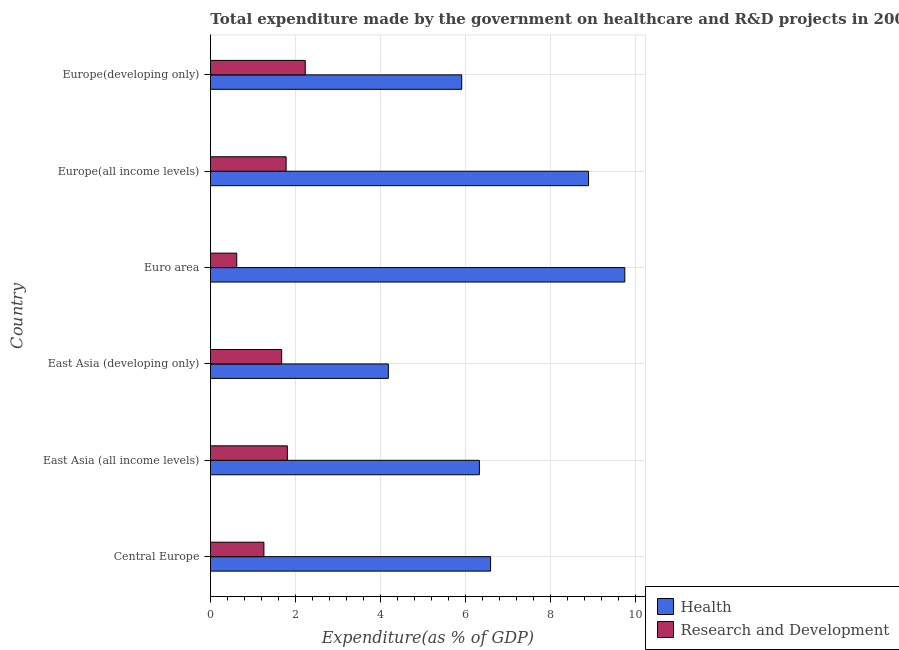How many groups of bars are there?
Your answer should be compact. 6. Are the number of bars per tick equal to the number of legend labels?
Make the answer very short. Yes. Are the number of bars on each tick of the Y-axis equal?
Give a very brief answer. Yes. What is the label of the 4th group of bars from the top?
Give a very brief answer. East Asia (developing only). What is the expenditure in r&d in East Asia (developing only)?
Ensure brevity in your answer.  1.67. Across all countries, what is the maximum expenditure in healthcare?
Ensure brevity in your answer.  9.74. Across all countries, what is the minimum expenditure in r&d?
Your response must be concise. 0.62. In which country was the expenditure in healthcare maximum?
Offer a very short reply. Euro area. In which country was the expenditure in r&d minimum?
Provide a short and direct response. Euro area. What is the total expenditure in r&d in the graph?
Your answer should be compact. 9.36. What is the difference between the expenditure in r&d in Central Europe and that in East Asia (developing only)?
Your answer should be compact. -0.42. What is the difference between the expenditure in healthcare in Central Europe and the expenditure in r&d in Europe(all income levels)?
Provide a succinct answer. 4.81. What is the average expenditure in healthcare per country?
Give a very brief answer. 6.94. What is the difference between the expenditure in healthcare and expenditure in r&d in Europe(all income levels)?
Your answer should be very brief. 7.11. In how many countries, is the expenditure in r&d greater than 4 %?
Make the answer very short. 0. What is the ratio of the expenditure in healthcare in East Asia (all income levels) to that in Europe(developing only)?
Offer a very short reply. 1.07. What is the difference between the highest and the second highest expenditure in healthcare?
Your answer should be very brief. 0.85. What is the difference between the highest and the lowest expenditure in healthcare?
Offer a very short reply. 5.56. What does the 2nd bar from the top in East Asia (developing only) represents?
Your answer should be very brief. Health. What does the 2nd bar from the bottom in Europe(developing only) represents?
Make the answer very short. Research and Development. Are the values on the major ticks of X-axis written in scientific E-notation?
Make the answer very short. No. Does the graph contain grids?
Your answer should be very brief. Yes. How are the legend labels stacked?
Offer a terse response. Vertical. What is the title of the graph?
Make the answer very short. Total expenditure made by the government on healthcare and R&D projects in 2007. Does "Lowest 20% of population" appear as one of the legend labels in the graph?
Your response must be concise. No. What is the label or title of the X-axis?
Make the answer very short. Expenditure(as % of GDP). What is the Expenditure(as % of GDP) of Health in Central Europe?
Provide a succinct answer. 6.59. What is the Expenditure(as % of GDP) in Research and Development in Central Europe?
Offer a very short reply. 1.26. What is the Expenditure(as % of GDP) of Health in East Asia (all income levels)?
Offer a very short reply. 6.32. What is the Expenditure(as % of GDP) of Research and Development in East Asia (all income levels)?
Your answer should be compact. 1.81. What is the Expenditure(as % of GDP) of Health in East Asia (developing only)?
Your response must be concise. 4.18. What is the Expenditure(as % of GDP) in Research and Development in East Asia (developing only)?
Offer a terse response. 1.67. What is the Expenditure(as % of GDP) of Health in Euro area?
Offer a terse response. 9.74. What is the Expenditure(as % of GDP) of Research and Development in Euro area?
Offer a very short reply. 0.62. What is the Expenditure(as % of GDP) in Health in Europe(all income levels)?
Make the answer very short. 8.89. What is the Expenditure(as % of GDP) of Research and Development in Europe(all income levels)?
Offer a very short reply. 1.78. What is the Expenditure(as % of GDP) in Health in Europe(developing only)?
Your response must be concise. 5.91. What is the Expenditure(as % of GDP) of Research and Development in Europe(developing only)?
Keep it short and to the point. 2.23. Across all countries, what is the maximum Expenditure(as % of GDP) in Health?
Your answer should be compact. 9.74. Across all countries, what is the maximum Expenditure(as % of GDP) in Research and Development?
Offer a very short reply. 2.23. Across all countries, what is the minimum Expenditure(as % of GDP) in Health?
Provide a short and direct response. 4.18. Across all countries, what is the minimum Expenditure(as % of GDP) of Research and Development?
Your answer should be compact. 0.62. What is the total Expenditure(as % of GDP) of Health in the graph?
Keep it short and to the point. 41.63. What is the total Expenditure(as % of GDP) of Research and Development in the graph?
Offer a terse response. 9.36. What is the difference between the Expenditure(as % of GDP) of Health in Central Europe and that in East Asia (all income levels)?
Your answer should be compact. 0.26. What is the difference between the Expenditure(as % of GDP) of Research and Development in Central Europe and that in East Asia (all income levels)?
Make the answer very short. -0.55. What is the difference between the Expenditure(as % of GDP) of Health in Central Europe and that in East Asia (developing only)?
Provide a short and direct response. 2.4. What is the difference between the Expenditure(as % of GDP) in Research and Development in Central Europe and that in East Asia (developing only)?
Your response must be concise. -0.42. What is the difference between the Expenditure(as % of GDP) of Health in Central Europe and that in Euro area?
Make the answer very short. -3.16. What is the difference between the Expenditure(as % of GDP) of Research and Development in Central Europe and that in Euro area?
Keep it short and to the point. 0.64. What is the difference between the Expenditure(as % of GDP) in Health in Central Europe and that in Europe(all income levels)?
Your answer should be compact. -2.3. What is the difference between the Expenditure(as % of GDP) in Research and Development in Central Europe and that in Europe(all income levels)?
Provide a short and direct response. -0.52. What is the difference between the Expenditure(as % of GDP) of Health in Central Europe and that in Europe(developing only)?
Offer a terse response. 0.68. What is the difference between the Expenditure(as % of GDP) in Research and Development in Central Europe and that in Europe(developing only)?
Your answer should be compact. -0.97. What is the difference between the Expenditure(as % of GDP) in Health in East Asia (all income levels) and that in East Asia (developing only)?
Your answer should be very brief. 2.14. What is the difference between the Expenditure(as % of GDP) in Research and Development in East Asia (all income levels) and that in East Asia (developing only)?
Offer a terse response. 0.13. What is the difference between the Expenditure(as % of GDP) of Health in East Asia (all income levels) and that in Euro area?
Your response must be concise. -3.42. What is the difference between the Expenditure(as % of GDP) of Research and Development in East Asia (all income levels) and that in Euro area?
Provide a succinct answer. 1.19. What is the difference between the Expenditure(as % of GDP) in Health in East Asia (all income levels) and that in Europe(all income levels)?
Your answer should be very brief. -2.57. What is the difference between the Expenditure(as % of GDP) in Research and Development in East Asia (all income levels) and that in Europe(all income levels)?
Give a very brief answer. 0.03. What is the difference between the Expenditure(as % of GDP) in Health in East Asia (all income levels) and that in Europe(developing only)?
Your answer should be compact. 0.42. What is the difference between the Expenditure(as % of GDP) of Research and Development in East Asia (all income levels) and that in Europe(developing only)?
Provide a short and direct response. -0.42. What is the difference between the Expenditure(as % of GDP) in Health in East Asia (developing only) and that in Euro area?
Your answer should be very brief. -5.56. What is the difference between the Expenditure(as % of GDP) of Research and Development in East Asia (developing only) and that in Euro area?
Provide a succinct answer. 1.06. What is the difference between the Expenditure(as % of GDP) in Health in East Asia (developing only) and that in Europe(all income levels)?
Your response must be concise. -4.71. What is the difference between the Expenditure(as % of GDP) in Research and Development in East Asia (developing only) and that in Europe(all income levels)?
Ensure brevity in your answer.  -0.1. What is the difference between the Expenditure(as % of GDP) in Health in East Asia (developing only) and that in Europe(developing only)?
Ensure brevity in your answer.  -1.73. What is the difference between the Expenditure(as % of GDP) in Research and Development in East Asia (developing only) and that in Europe(developing only)?
Provide a short and direct response. -0.55. What is the difference between the Expenditure(as % of GDP) of Health in Euro area and that in Europe(all income levels)?
Your response must be concise. 0.85. What is the difference between the Expenditure(as % of GDP) of Research and Development in Euro area and that in Europe(all income levels)?
Provide a short and direct response. -1.16. What is the difference between the Expenditure(as % of GDP) of Health in Euro area and that in Europe(developing only)?
Your answer should be compact. 3.83. What is the difference between the Expenditure(as % of GDP) in Research and Development in Euro area and that in Europe(developing only)?
Give a very brief answer. -1.61. What is the difference between the Expenditure(as % of GDP) in Health in Europe(all income levels) and that in Europe(developing only)?
Provide a succinct answer. 2.98. What is the difference between the Expenditure(as % of GDP) in Research and Development in Europe(all income levels) and that in Europe(developing only)?
Your answer should be very brief. -0.45. What is the difference between the Expenditure(as % of GDP) in Health in Central Europe and the Expenditure(as % of GDP) in Research and Development in East Asia (all income levels)?
Provide a short and direct response. 4.78. What is the difference between the Expenditure(as % of GDP) in Health in Central Europe and the Expenditure(as % of GDP) in Research and Development in East Asia (developing only)?
Provide a short and direct response. 4.91. What is the difference between the Expenditure(as % of GDP) in Health in Central Europe and the Expenditure(as % of GDP) in Research and Development in Euro area?
Ensure brevity in your answer.  5.97. What is the difference between the Expenditure(as % of GDP) in Health in Central Europe and the Expenditure(as % of GDP) in Research and Development in Europe(all income levels)?
Ensure brevity in your answer.  4.81. What is the difference between the Expenditure(as % of GDP) in Health in Central Europe and the Expenditure(as % of GDP) in Research and Development in Europe(developing only)?
Offer a terse response. 4.36. What is the difference between the Expenditure(as % of GDP) in Health in East Asia (all income levels) and the Expenditure(as % of GDP) in Research and Development in East Asia (developing only)?
Provide a short and direct response. 4.65. What is the difference between the Expenditure(as % of GDP) of Health in East Asia (all income levels) and the Expenditure(as % of GDP) of Research and Development in Euro area?
Offer a terse response. 5.71. What is the difference between the Expenditure(as % of GDP) of Health in East Asia (all income levels) and the Expenditure(as % of GDP) of Research and Development in Europe(all income levels)?
Your response must be concise. 4.54. What is the difference between the Expenditure(as % of GDP) of Health in East Asia (all income levels) and the Expenditure(as % of GDP) of Research and Development in Europe(developing only)?
Ensure brevity in your answer.  4.09. What is the difference between the Expenditure(as % of GDP) of Health in East Asia (developing only) and the Expenditure(as % of GDP) of Research and Development in Euro area?
Your answer should be very brief. 3.56. What is the difference between the Expenditure(as % of GDP) in Health in East Asia (developing only) and the Expenditure(as % of GDP) in Research and Development in Europe(all income levels)?
Make the answer very short. 2.4. What is the difference between the Expenditure(as % of GDP) in Health in East Asia (developing only) and the Expenditure(as % of GDP) in Research and Development in Europe(developing only)?
Offer a very short reply. 1.95. What is the difference between the Expenditure(as % of GDP) in Health in Euro area and the Expenditure(as % of GDP) in Research and Development in Europe(all income levels)?
Provide a succinct answer. 7.96. What is the difference between the Expenditure(as % of GDP) of Health in Euro area and the Expenditure(as % of GDP) of Research and Development in Europe(developing only)?
Make the answer very short. 7.51. What is the difference between the Expenditure(as % of GDP) in Health in Europe(all income levels) and the Expenditure(as % of GDP) in Research and Development in Europe(developing only)?
Offer a very short reply. 6.66. What is the average Expenditure(as % of GDP) in Health per country?
Offer a very short reply. 6.94. What is the average Expenditure(as % of GDP) of Research and Development per country?
Ensure brevity in your answer.  1.56. What is the difference between the Expenditure(as % of GDP) of Health and Expenditure(as % of GDP) of Research and Development in Central Europe?
Keep it short and to the point. 5.33. What is the difference between the Expenditure(as % of GDP) of Health and Expenditure(as % of GDP) of Research and Development in East Asia (all income levels)?
Your answer should be very brief. 4.52. What is the difference between the Expenditure(as % of GDP) of Health and Expenditure(as % of GDP) of Research and Development in East Asia (developing only)?
Provide a short and direct response. 2.51. What is the difference between the Expenditure(as % of GDP) of Health and Expenditure(as % of GDP) of Research and Development in Euro area?
Keep it short and to the point. 9.12. What is the difference between the Expenditure(as % of GDP) in Health and Expenditure(as % of GDP) in Research and Development in Europe(all income levels)?
Offer a very short reply. 7.11. What is the difference between the Expenditure(as % of GDP) in Health and Expenditure(as % of GDP) in Research and Development in Europe(developing only)?
Provide a succinct answer. 3.68. What is the ratio of the Expenditure(as % of GDP) of Health in Central Europe to that in East Asia (all income levels)?
Offer a very short reply. 1.04. What is the ratio of the Expenditure(as % of GDP) in Research and Development in Central Europe to that in East Asia (all income levels)?
Keep it short and to the point. 0.7. What is the ratio of the Expenditure(as % of GDP) of Health in Central Europe to that in East Asia (developing only)?
Give a very brief answer. 1.57. What is the ratio of the Expenditure(as % of GDP) of Research and Development in Central Europe to that in East Asia (developing only)?
Provide a succinct answer. 0.75. What is the ratio of the Expenditure(as % of GDP) in Health in Central Europe to that in Euro area?
Your answer should be very brief. 0.68. What is the ratio of the Expenditure(as % of GDP) of Research and Development in Central Europe to that in Euro area?
Your response must be concise. 2.03. What is the ratio of the Expenditure(as % of GDP) in Health in Central Europe to that in Europe(all income levels)?
Offer a terse response. 0.74. What is the ratio of the Expenditure(as % of GDP) of Research and Development in Central Europe to that in Europe(all income levels)?
Provide a short and direct response. 0.71. What is the ratio of the Expenditure(as % of GDP) in Health in Central Europe to that in Europe(developing only)?
Provide a succinct answer. 1.11. What is the ratio of the Expenditure(as % of GDP) of Research and Development in Central Europe to that in Europe(developing only)?
Ensure brevity in your answer.  0.56. What is the ratio of the Expenditure(as % of GDP) in Health in East Asia (all income levels) to that in East Asia (developing only)?
Make the answer very short. 1.51. What is the ratio of the Expenditure(as % of GDP) in Research and Development in East Asia (all income levels) to that in East Asia (developing only)?
Give a very brief answer. 1.08. What is the ratio of the Expenditure(as % of GDP) of Health in East Asia (all income levels) to that in Euro area?
Make the answer very short. 0.65. What is the ratio of the Expenditure(as % of GDP) in Research and Development in East Asia (all income levels) to that in Euro area?
Keep it short and to the point. 2.93. What is the ratio of the Expenditure(as % of GDP) of Health in East Asia (all income levels) to that in Europe(all income levels)?
Your response must be concise. 0.71. What is the ratio of the Expenditure(as % of GDP) of Research and Development in East Asia (all income levels) to that in Europe(all income levels)?
Provide a short and direct response. 1.02. What is the ratio of the Expenditure(as % of GDP) of Health in East Asia (all income levels) to that in Europe(developing only)?
Provide a short and direct response. 1.07. What is the ratio of the Expenditure(as % of GDP) in Research and Development in East Asia (all income levels) to that in Europe(developing only)?
Provide a short and direct response. 0.81. What is the ratio of the Expenditure(as % of GDP) of Health in East Asia (developing only) to that in Euro area?
Your answer should be very brief. 0.43. What is the ratio of the Expenditure(as % of GDP) of Research and Development in East Asia (developing only) to that in Euro area?
Provide a short and direct response. 2.71. What is the ratio of the Expenditure(as % of GDP) in Health in East Asia (developing only) to that in Europe(all income levels)?
Provide a short and direct response. 0.47. What is the ratio of the Expenditure(as % of GDP) in Health in East Asia (developing only) to that in Europe(developing only)?
Your response must be concise. 0.71. What is the ratio of the Expenditure(as % of GDP) of Research and Development in East Asia (developing only) to that in Europe(developing only)?
Provide a short and direct response. 0.75. What is the ratio of the Expenditure(as % of GDP) in Health in Euro area to that in Europe(all income levels)?
Provide a succinct answer. 1.1. What is the ratio of the Expenditure(as % of GDP) in Research and Development in Euro area to that in Europe(all income levels)?
Give a very brief answer. 0.35. What is the ratio of the Expenditure(as % of GDP) in Health in Euro area to that in Europe(developing only)?
Your response must be concise. 1.65. What is the ratio of the Expenditure(as % of GDP) of Research and Development in Euro area to that in Europe(developing only)?
Make the answer very short. 0.28. What is the ratio of the Expenditure(as % of GDP) in Health in Europe(all income levels) to that in Europe(developing only)?
Your answer should be compact. 1.5. What is the ratio of the Expenditure(as % of GDP) in Research and Development in Europe(all income levels) to that in Europe(developing only)?
Offer a very short reply. 0.8. What is the difference between the highest and the second highest Expenditure(as % of GDP) of Health?
Your answer should be very brief. 0.85. What is the difference between the highest and the second highest Expenditure(as % of GDP) in Research and Development?
Ensure brevity in your answer.  0.42. What is the difference between the highest and the lowest Expenditure(as % of GDP) of Health?
Offer a very short reply. 5.56. What is the difference between the highest and the lowest Expenditure(as % of GDP) of Research and Development?
Your answer should be compact. 1.61. 